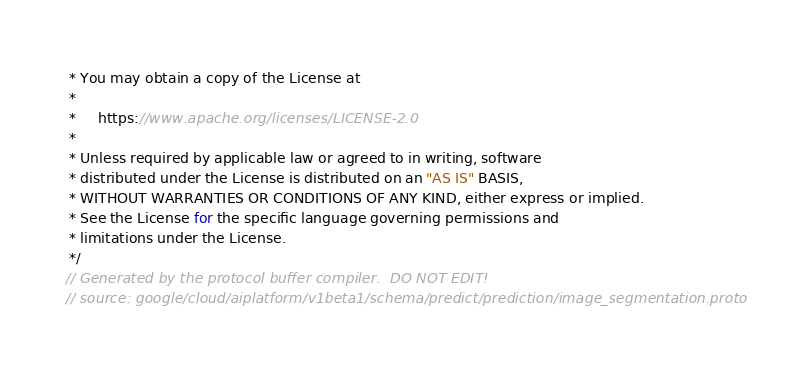<code> <loc_0><loc_0><loc_500><loc_500><_Java_> * You may obtain a copy of the License at
 *
 *     https://www.apache.org/licenses/LICENSE-2.0
 *
 * Unless required by applicable law or agreed to in writing, software
 * distributed under the License is distributed on an "AS IS" BASIS,
 * WITHOUT WARRANTIES OR CONDITIONS OF ANY KIND, either express or implied.
 * See the License for the specific language governing permissions and
 * limitations under the License.
 */
// Generated by the protocol buffer compiler.  DO NOT EDIT!
// source: google/cloud/aiplatform/v1beta1/schema/predict/prediction/image_segmentation.proto
</code> 